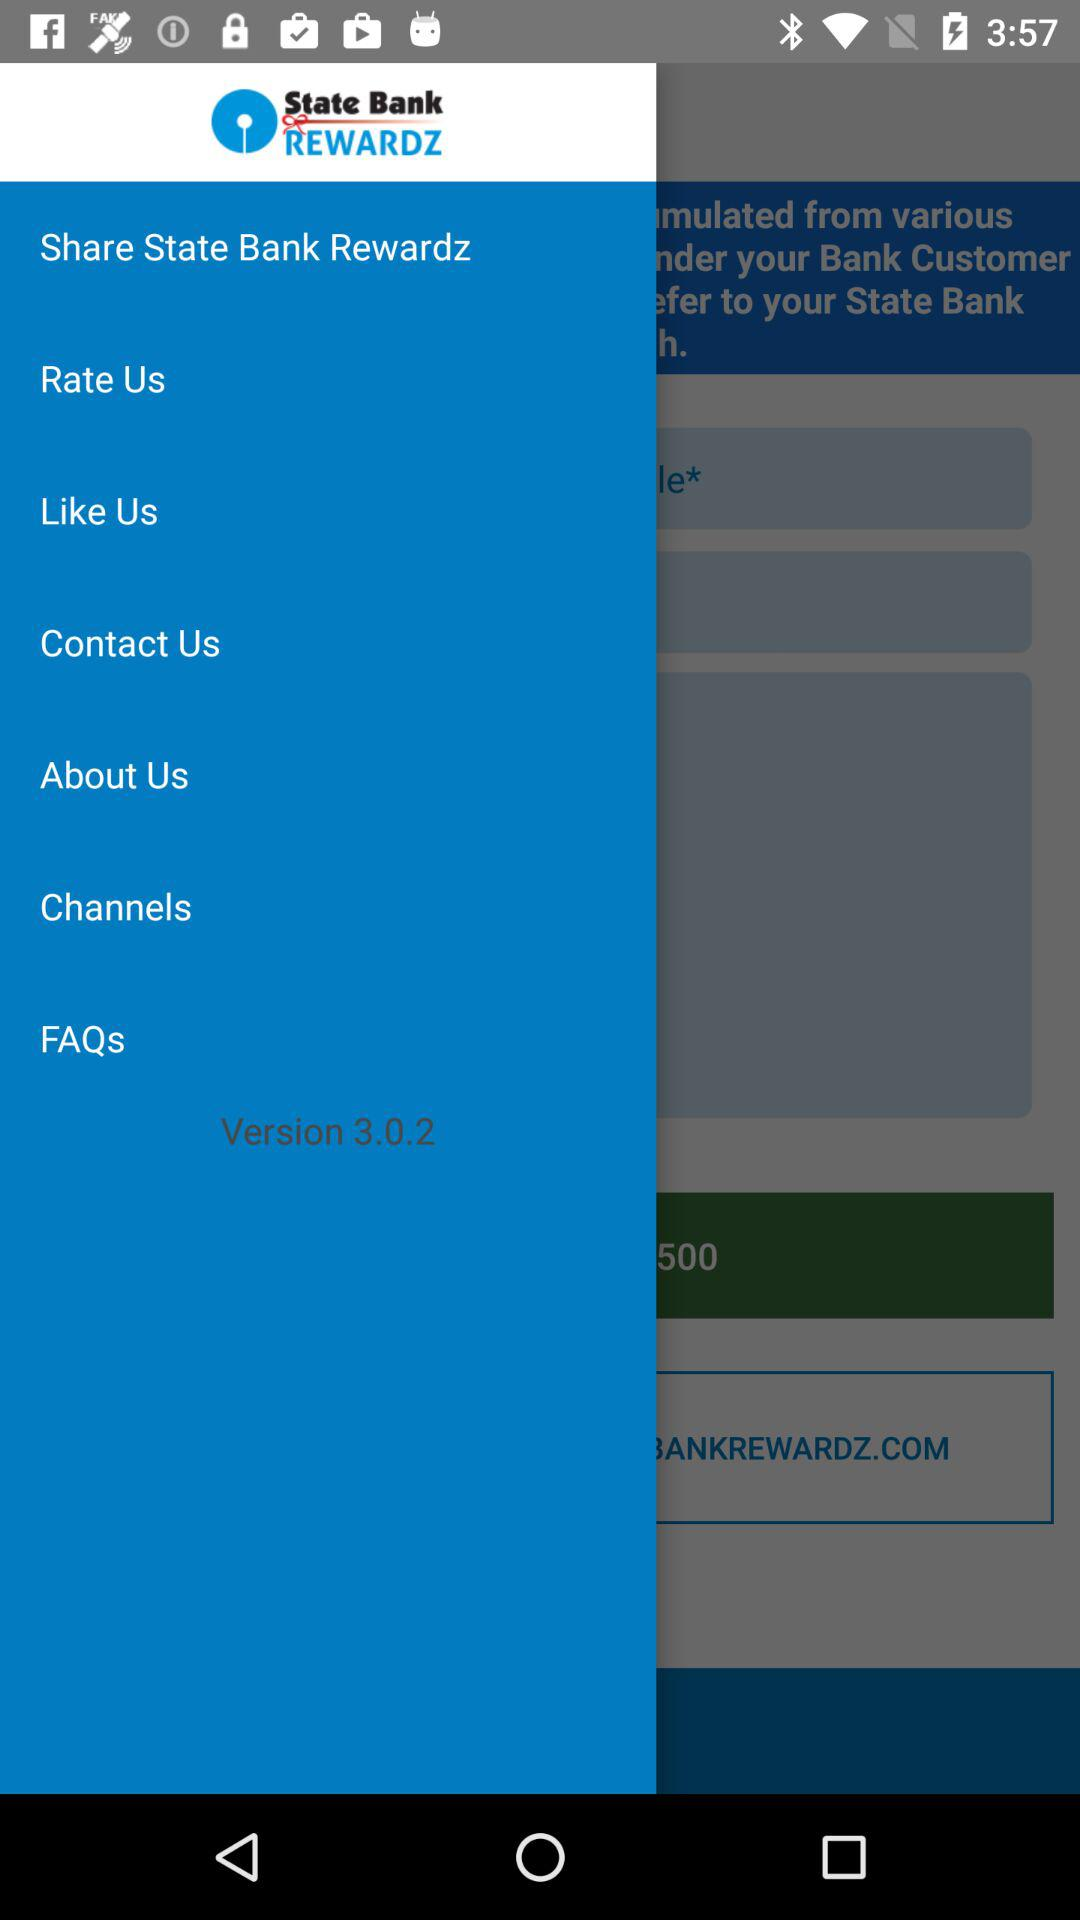What is the version? The version is 3.0.2. 